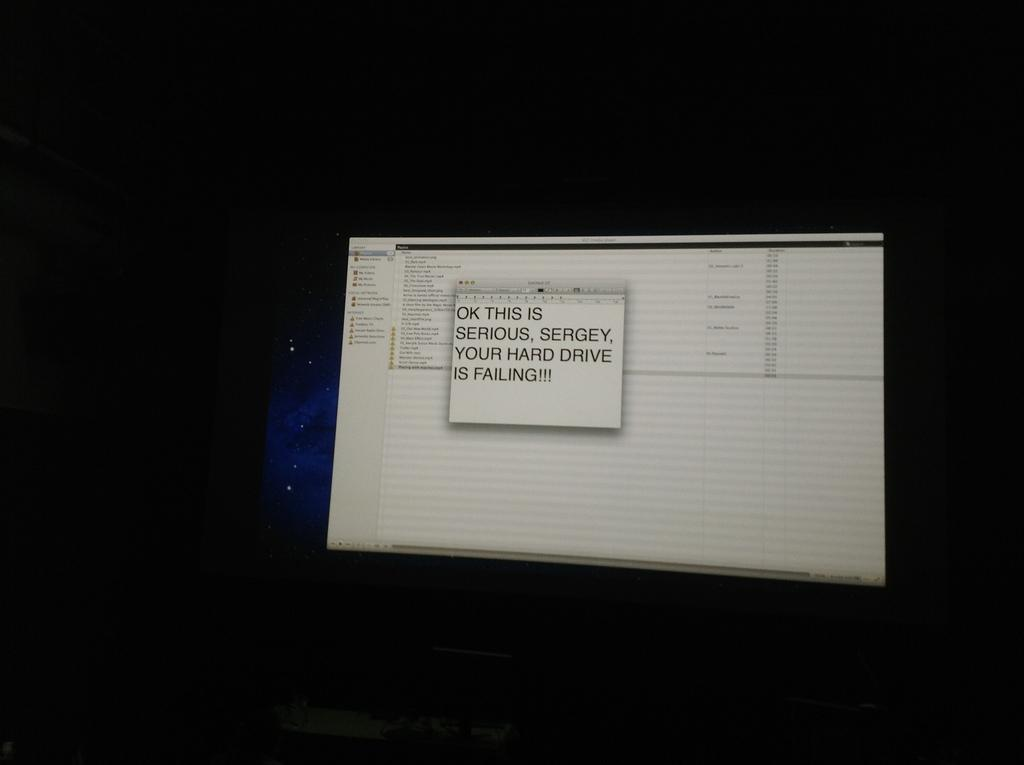Provide a one-sentence caption for the provided image. Sergey's has a serious problem, their hard drive is failing. 